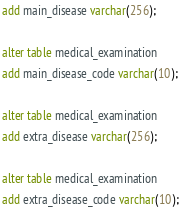Convert code to text. <code><loc_0><loc_0><loc_500><loc_500><_SQL_>add main_disease varchar(256);

alter table medical_examination 
add main_disease_code varchar(10);

alter table medical_examination 
add extra_disease varchar(256);

alter table medical_examination 
add extra_disease_code varchar(10);</code> 